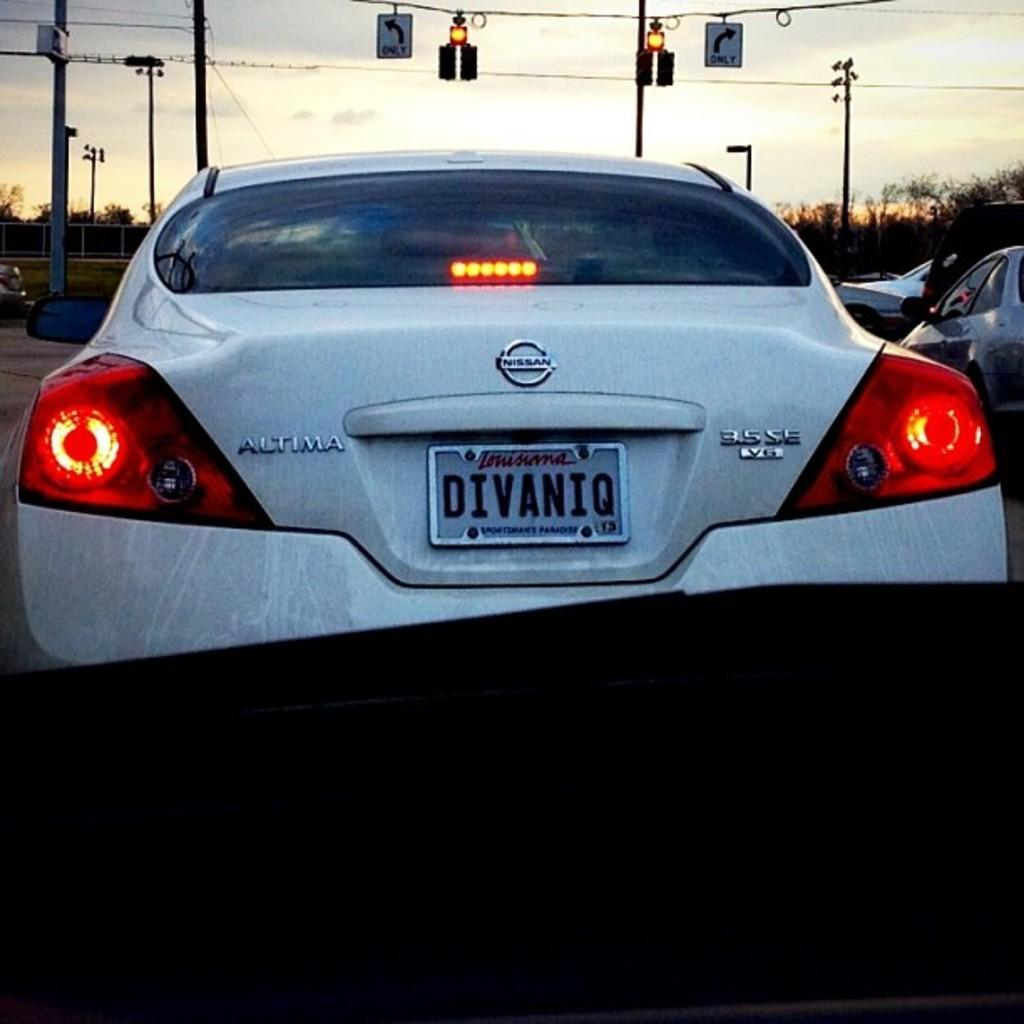What can be seen on the road in the image? There are vehicles on the road in the image. What is present in the background of the image? There is a railing and trees in the background of the image. What is visible at the top of the image? There are signals and sign boards at the top of the image. How many crows are sitting on the railing in the image? There are no crows present in the image; it features vehicles on the road, a railing, trees, signals, and sign boards. What type of soap is advertised on the sign board in the image? There is no soap advertised on the sign board in the image; the sign boards contain information related to the road and traffic. 